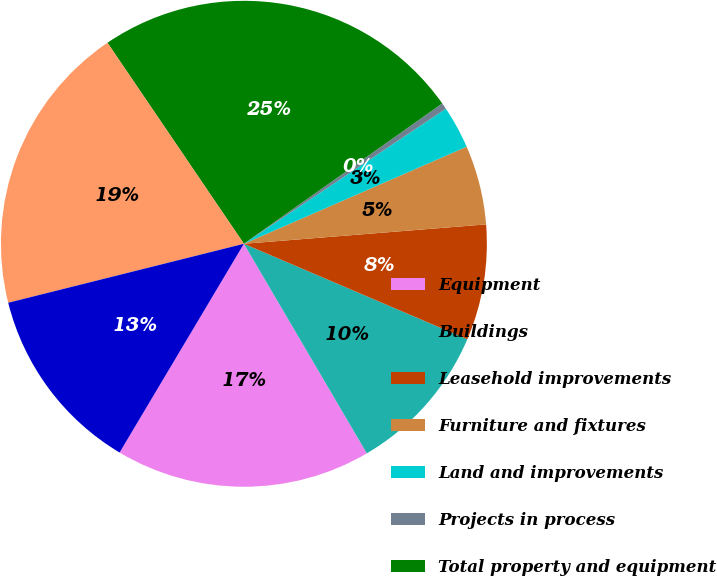Convert chart to OTSL. <chart><loc_0><loc_0><loc_500><loc_500><pie_chart><fcel>Equipment<fcel>Buildings<fcel>Leasehold improvements<fcel>Furniture and fixtures<fcel>Land and improvements<fcel>Projects in process<fcel>Total property and equipment<fcel>Less accumulated depreciation<fcel>Property and equipment net<nl><fcel>16.99%<fcel>10.13%<fcel>7.7%<fcel>5.27%<fcel>2.84%<fcel>0.42%<fcel>24.69%<fcel>19.41%<fcel>12.55%<nl></chart> 